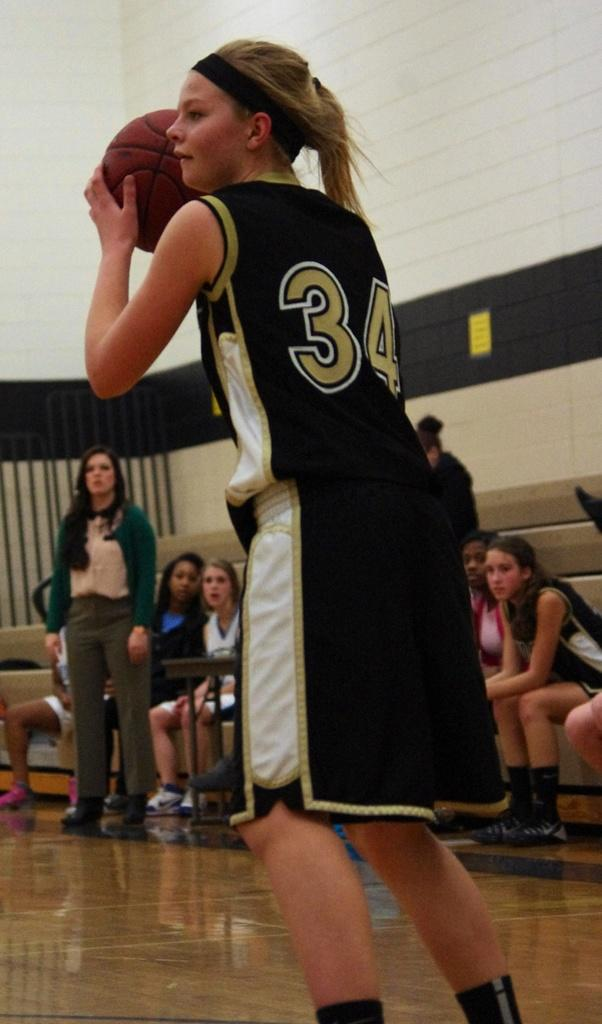<image>
Share a concise interpretation of the image provided. A girl playing basketball is wearing number 34. 